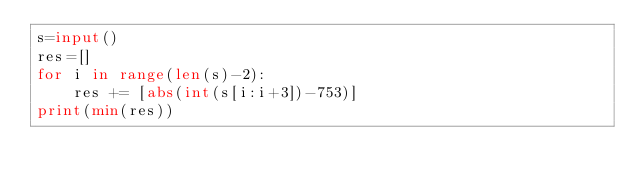Convert code to text. <code><loc_0><loc_0><loc_500><loc_500><_Python_>s=input()
res=[]
for i in range(len(s)-2):
    res += [abs(int(s[i:i+3])-753)]
print(min(res))</code> 